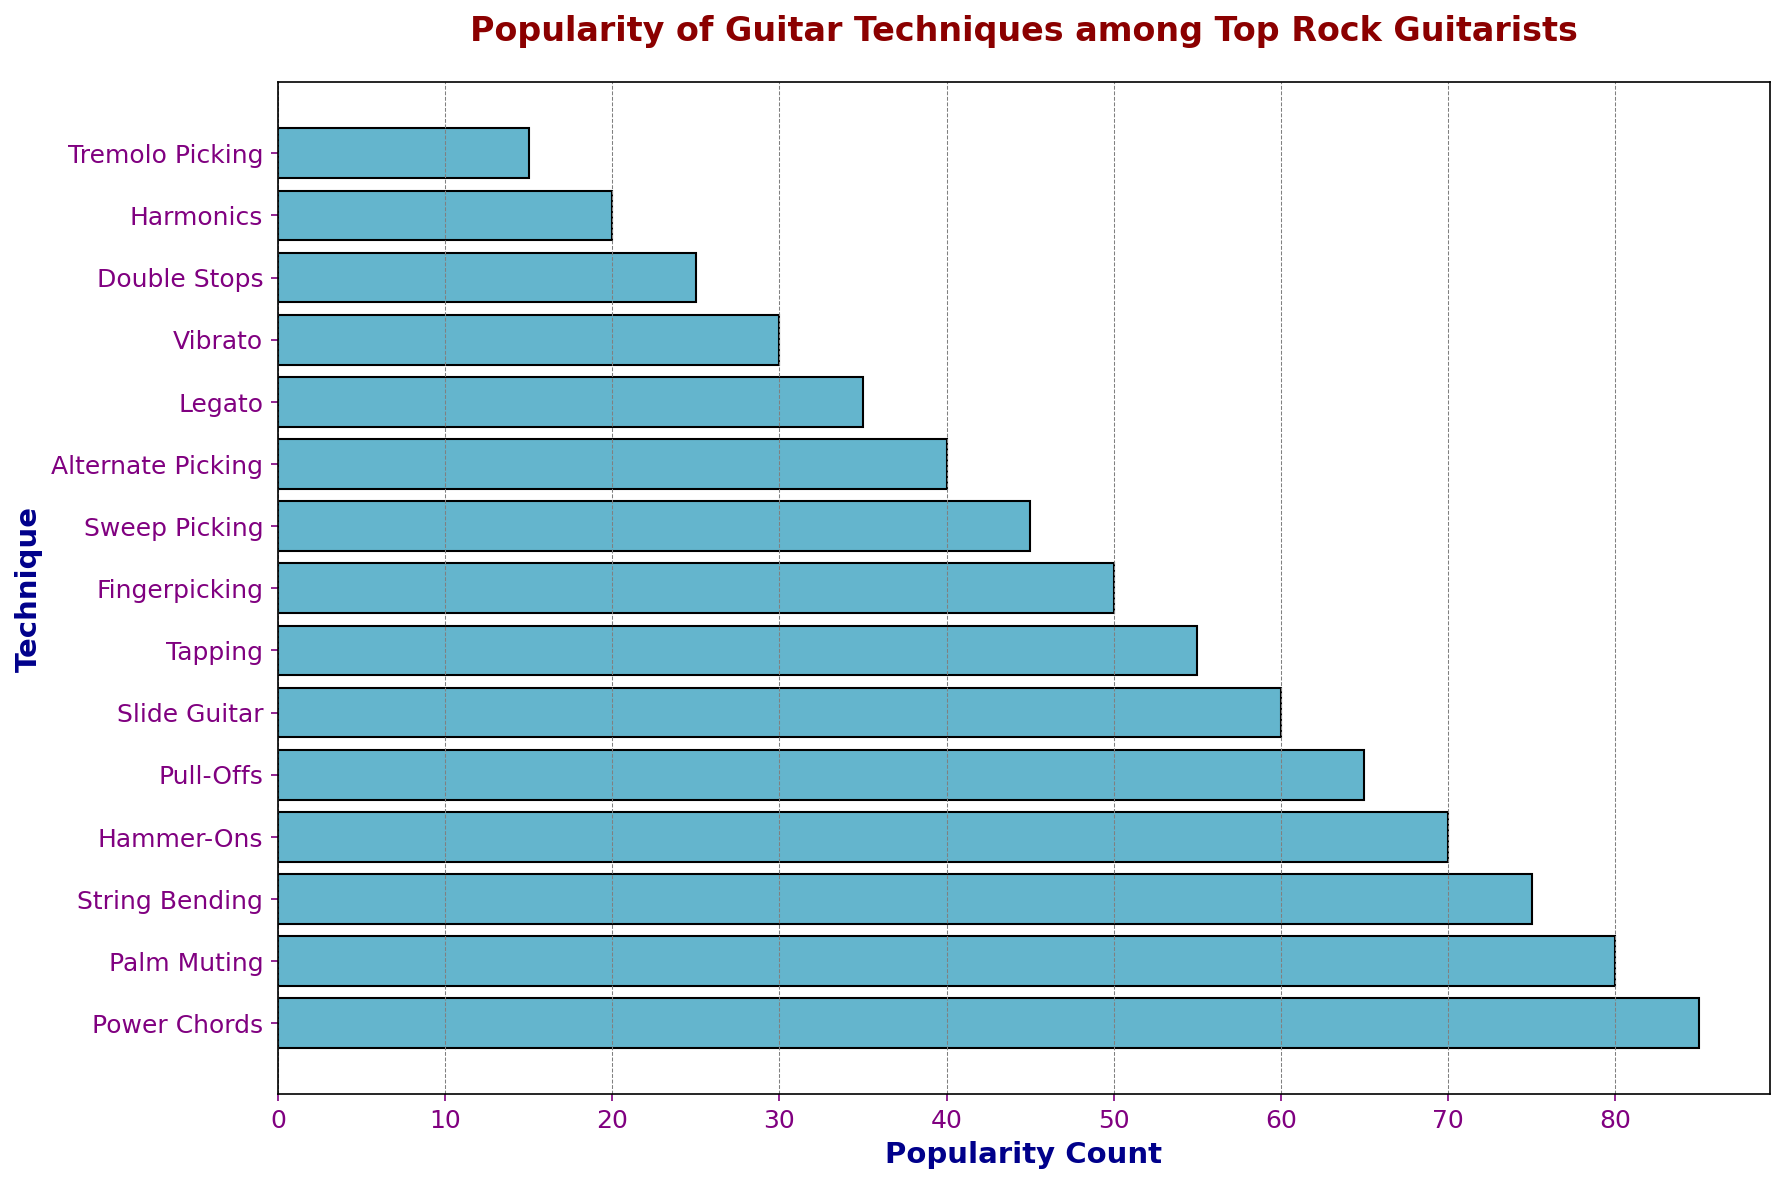What's the most popular guitar technique? The tallest bar on the chart represents the technique with the highest popularity count. By looking at the chart, the bar for "Power Chords" is the tallest.
Answer: Power Chords Which technique is the least popular, and what is its popularity count? The shortest bar on the chart represents the least popular technique. The bar for "Tremolo Picking" is the shortest, with a popularity count of 15.
Answer: Tremolo Picking, 15 How much more popular are Power Chords compared to Alternate Picking? To find the difference, subtract the popularity count of Alternate Picking from that of Power Chords: 85 (Power Chords) - 40 (Alternate Picking) = 45.
Answer: 45 Which techniques have a popularity count greater than 70? By examining the chart, the techniques with bars that extend beyond the 70 mark are "Power Chords," "Palm Muting," and "String Bending."
Answer: Power Chords, Palm Muting, String Bending What is the total popularity count of Hammer-Ons, Pull-Offs, and Slide Guitar combined? Add the popularity counts of these three techniques: 70 (Hammer-Ons) + 65 (Pull-Offs) + 60 (Slide Guitar) = 195.
Answer: 195 Which technique has a higher popularity count: Tapping or Fingerpicking? By comparing the length of the bars for Tapping and Fingerpicking, the Tapping bar appears longer. Tapping has a popularity count of 55, whereas Fingerpicking has 50.
Answer: Tapping How many techniques have a popularity count of less than 50? By checking the chart, we count the bars with popularity counts less than 50: Sweep Picking (45), Alternate Picking (40), Legato (35), Vibrato (30), Double Stops (25), Harmonics (20), and Tremolo Picking (15). The total is 7 techniques.
Answer: 7 What is the average popularity count of the techniques Power Chords, Palm Muting, and String Bending? First, sum the popularity counts: 85 (Power Chords) + 80 (Palm Muting) + 75 (String Bending) = 240. Then, divide by the number of techniques: 240 / 3 = 80.
Answer: 80 Identify the techniques between 40 and 60 popularity count and list them. By observing the chart, the techniques within this range are Sweep Picking (45), Fingerpicking (50), and Tapping (55).
Answer: Sweep Picking, Fingerpicking, Tapping What is the sum of the popularity counts of the top five techniques? Add the popularity counts of the top five techniques: 85 (Power Chords) + 80 (Palm Muting) + 75 (String Bending) + 70 (Hammer-Ons) + 65 (Pull-Offs) = 375.
Answer: 375 